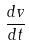<formula> <loc_0><loc_0><loc_500><loc_500>\frac { d v } { d t }</formula> 